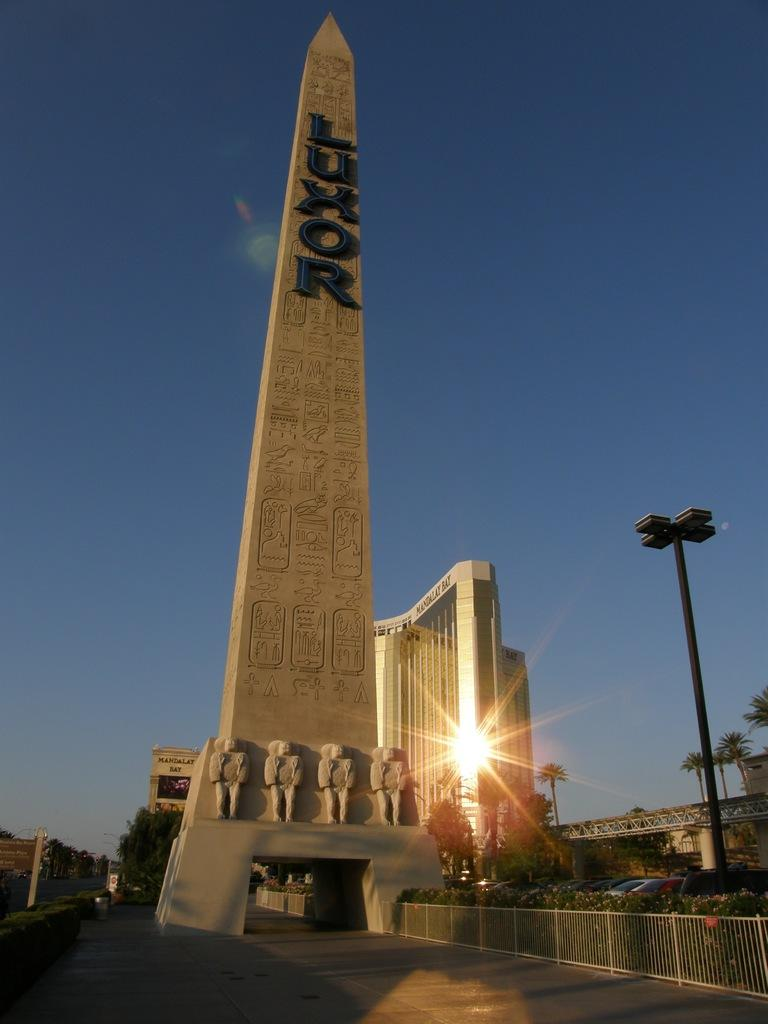What is the main structure in the picture? There is a tower in the picture. What other buildings or structures can be seen in the picture? There is a building in the picture. What is attached to the pole in the picture? There is a light attached to the pole in the picture. What type of vegetation is present in the picture? There are trees and plants in the picture. What is the condition of the sky in the picture? The sky is clear in the picture. What is the caption of the picture? There is no caption provided with the image, so it cannot be determined. Can you see the army marching in the picture? There is no army or any indication of military presence in the picture. 